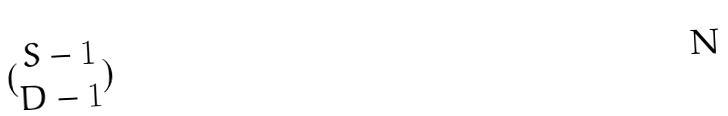<formula> <loc_0><loc_0><loc_500><loc_500>( \begin{matrix} S - 1 \\ D - 1 \end{matrix} )</formula> 